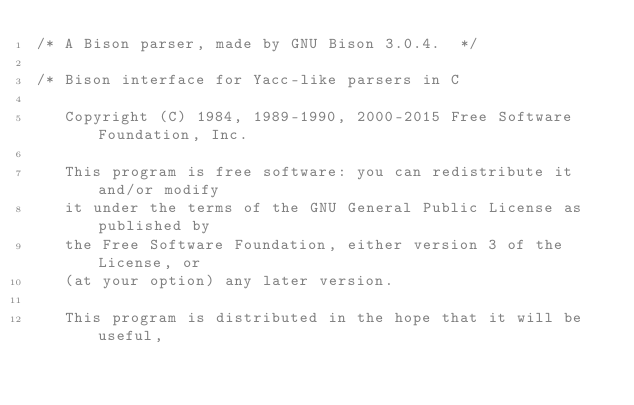Convert code to text. <code><loc_0><loc_0><loc_500><loc_500><_C_>/* A Bison parser, made by GNU Bison 3.0.4.  */

/* Bison interface for Yacc-like parsers in C

   Copyright (C) 1984, 1989-1990, 2000-2015 Free Software Foundation, Inc.

   This program is free software: you can redistribute it and/or modify
   it under the terms of the GNU General Public License as published by
   the Free Software Foundation, either version 3 of the License, or
   (at your option) any later version.

   This program is distributed in the hope that it will be useful,</code> 